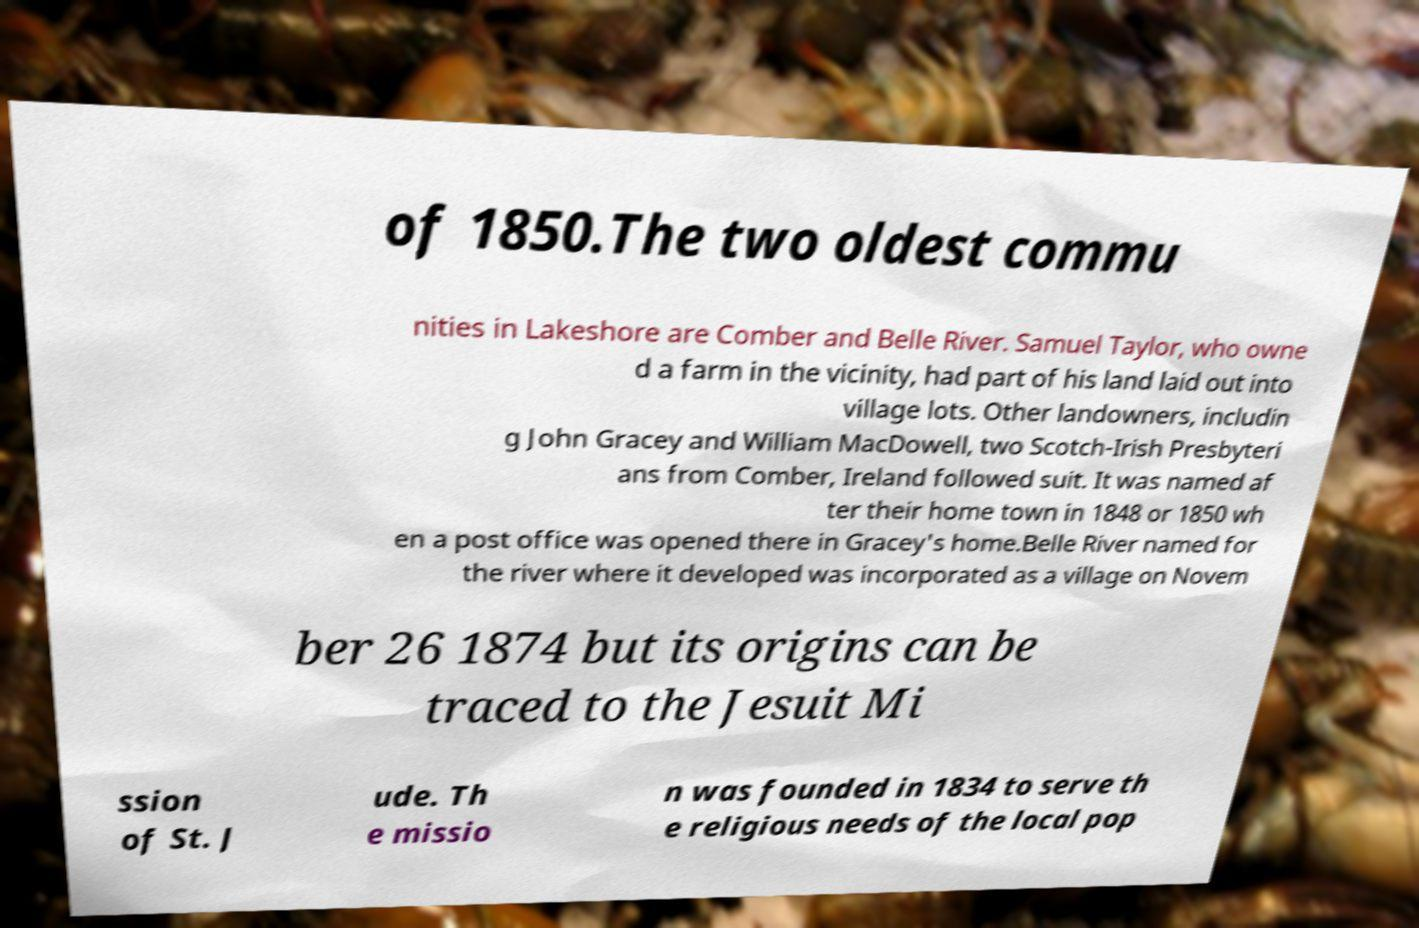What messages or text are displayed in this image? I need them in a readable, typed format. of 1850.The two oldest commu nities in Lakeshore are Comber and Belle River. Samuel Taylor, who owne d a farm in the vicinity, had part of his land laid out into village lots. Other landowners, includin g John Gracey and William MacDowell, two Scotch-Irish Presbyteri ans from Comber, Ireland followed suit. It was named af ter their home town in 1848 or 1850 wh en a post office was opened there in Gracey's home.Belle River named for the river where it developed was incorporated as a village on Novem ber 26 1874 but its origins can be traced to the Jesuit Mi ssion of St. J ude. Th e missio n was founded in 1834 to serve th e religious needs of the local pop 